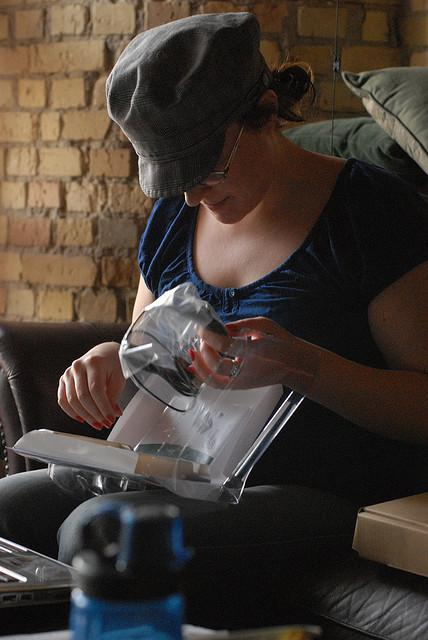What's the lady wearing on her head?

Choices:
A) hijab
B) glasses
C) nothing
D) cap cap 